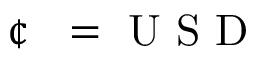<formula> <loc_0><loc_0><loc_500><loc_500>{ \text  cent }  =  U S D</formula> 